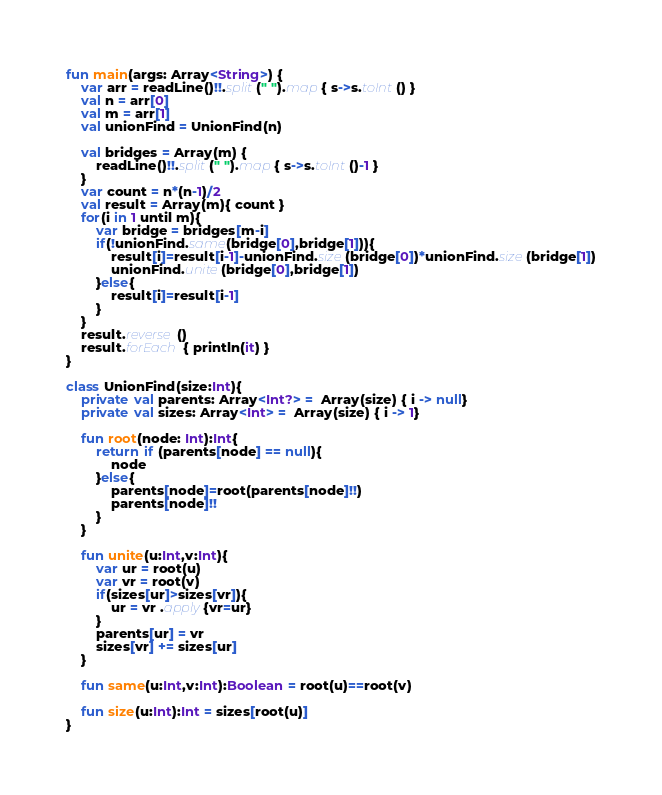<code> <loc_0><loc_0><loc_500><loc_500><_Kotlin_>fun main(args: Array<String>) {
    var arr = readLine()!!.split(" ").map { s->s.toInt() }
    val n = arr[0]
    val m = arr[1]
    val unionFind = UnionFind(n)

    val bridges = Array(m) {
        readLine()!!.split(" ").map { s->s.toInt()-1 }
    }
    var count = n*(n-1)/2
    val result = Array(m){ count }
    for(i in 1 until m){
        var bridge = bridges[m-i]
        if(!unionFind.same(bridge[0],bridge[1])){
            result[i]=result[i-1]-unionFind.size(bridge[0])*unionFind.size(bridge[1])
            unionFind.unite(bridge[0],bridge[1])
        }else{
            result[i]=result[i-1]
        }
    }
    result.reverse()
    result.forEach { println(it) }
}

class UnionFind(size:Int){
    private val parents: Array<Int?> =  Array(size) { i -> null}
    private val sizes: Array<Int> =  Array(size) { i -> 1}

    fun root(node: Int):Int{
        return if (parents[node] == null){
            node
        }else{
            parents[node]=root(parents[node]!!)
            parents[node]!!
        }
    }

    fun unite(u:Int,v:Int){
        var ur = root(u)
        var vr = root(v)
        if(sizes[ur]>sizes[vr]){
            ur = vr .apply{vr=ur}
        }
        parents[ur] = vr
        sizes[vr] += sizes[ur]
    }

    fun same(u:Int,v:Int):Boolean = root(u)==root(v)

    fun size(u:Int):Int = sizes[root(u)]
}</code> 